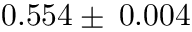<formula> <loc_0><loc_0><loc_500><loc_500>0 . 5 5 4 \pm \, 0 . 0 0 4</formula> 